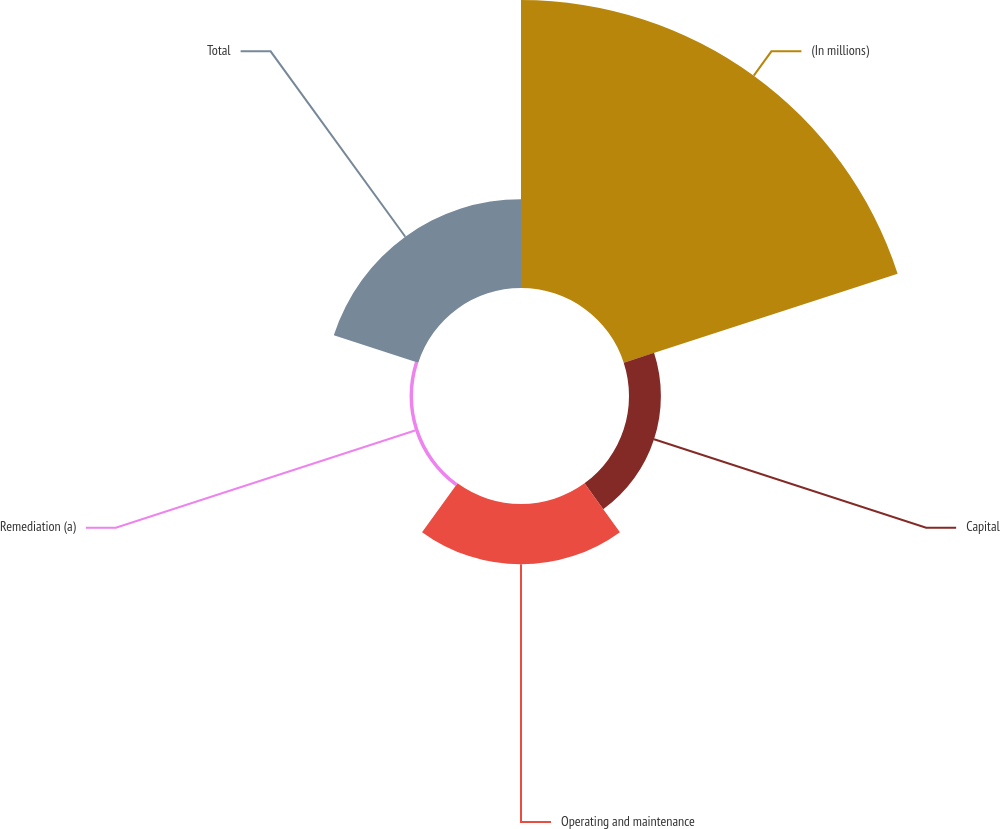Convert chart to OTSL. <chart><loc_0><loc_0><loc_500><loc_500><pie_chart><fcel>(In millions)<fcel>Capital<fcel>Operating and maintenance<fcel>Remediation (a)<fcel>Total<nl><fcel>60.95%<fcel>6.75%<fcel>12.77%<fcel>0.73%<fcel>18.8%<nl></chart> 